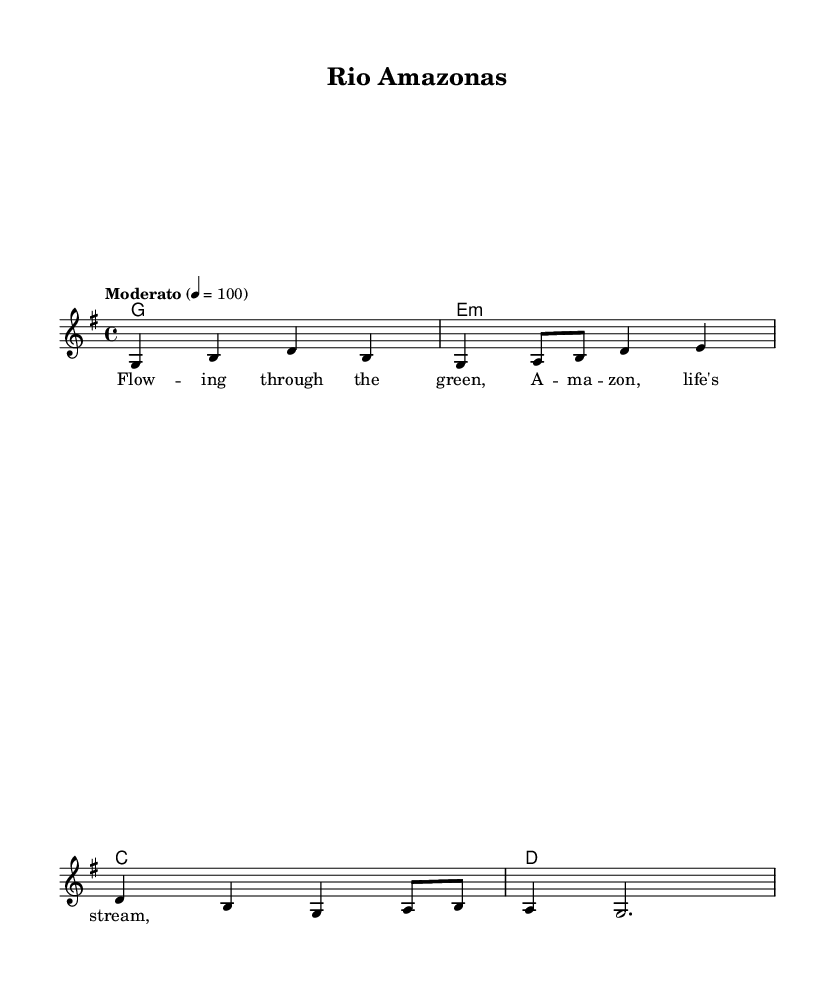What is the key signature of this music? The key signature is specified with the instruction "\key g \major", which indicates that there is one sharp (F#) in the key of G major.
Answer: G major What is the time signature of this music? The time signature is indicated by "\time 4/4", meaning there are four beats in a measure and the quarter note gets one beat.
Answer: 4/4 What is the tempo marking for this piece? The tempo is indicated by "\tempo 'Moderato' 4 = 100", which means to perform the piece at a moderate pace of 100 beats per minute.
Answer: Moderato How many measures are in the melody? The melody section contains a series of bars separated by vertical lines, and there are 4 measures present in the provided melody.
Answer: 4 What type of song is "Rio Amazonas"? Given the title and the lyrical content, it is inferred to be a folk song that expresses themes relating to the Amazon and its waterways.
Answer: Folk song Which note is the first note of the melody? The melody begins with the note "g" as indicated by the first note of the "melody" section written in the first measure of the notation.
Answer: g What is the lyrical theme represented in the song? The lyrics mention "Flowing through the green, Amazon, life's stream", indicating that the song reflects on the beauty and life-giving properties of the Amazon River.
Answer: Water conservation 